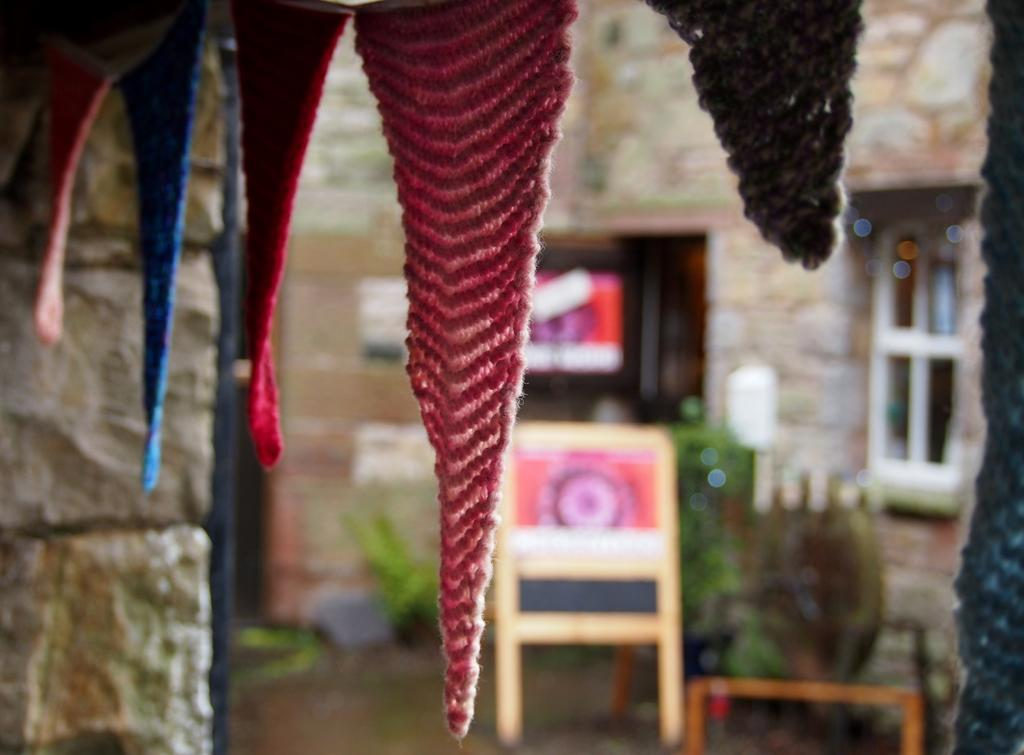What type of items can be seen in the image? There are different colored clothes in the image. What can be seen in the background of the image? There is a window and plants in the background of the image. How is the background of the image depicted? The background of the image is slightly blurry. What advice does the manager give to the family in the image? There is no manager or family present in the image, so it is not possible to answer that question. 